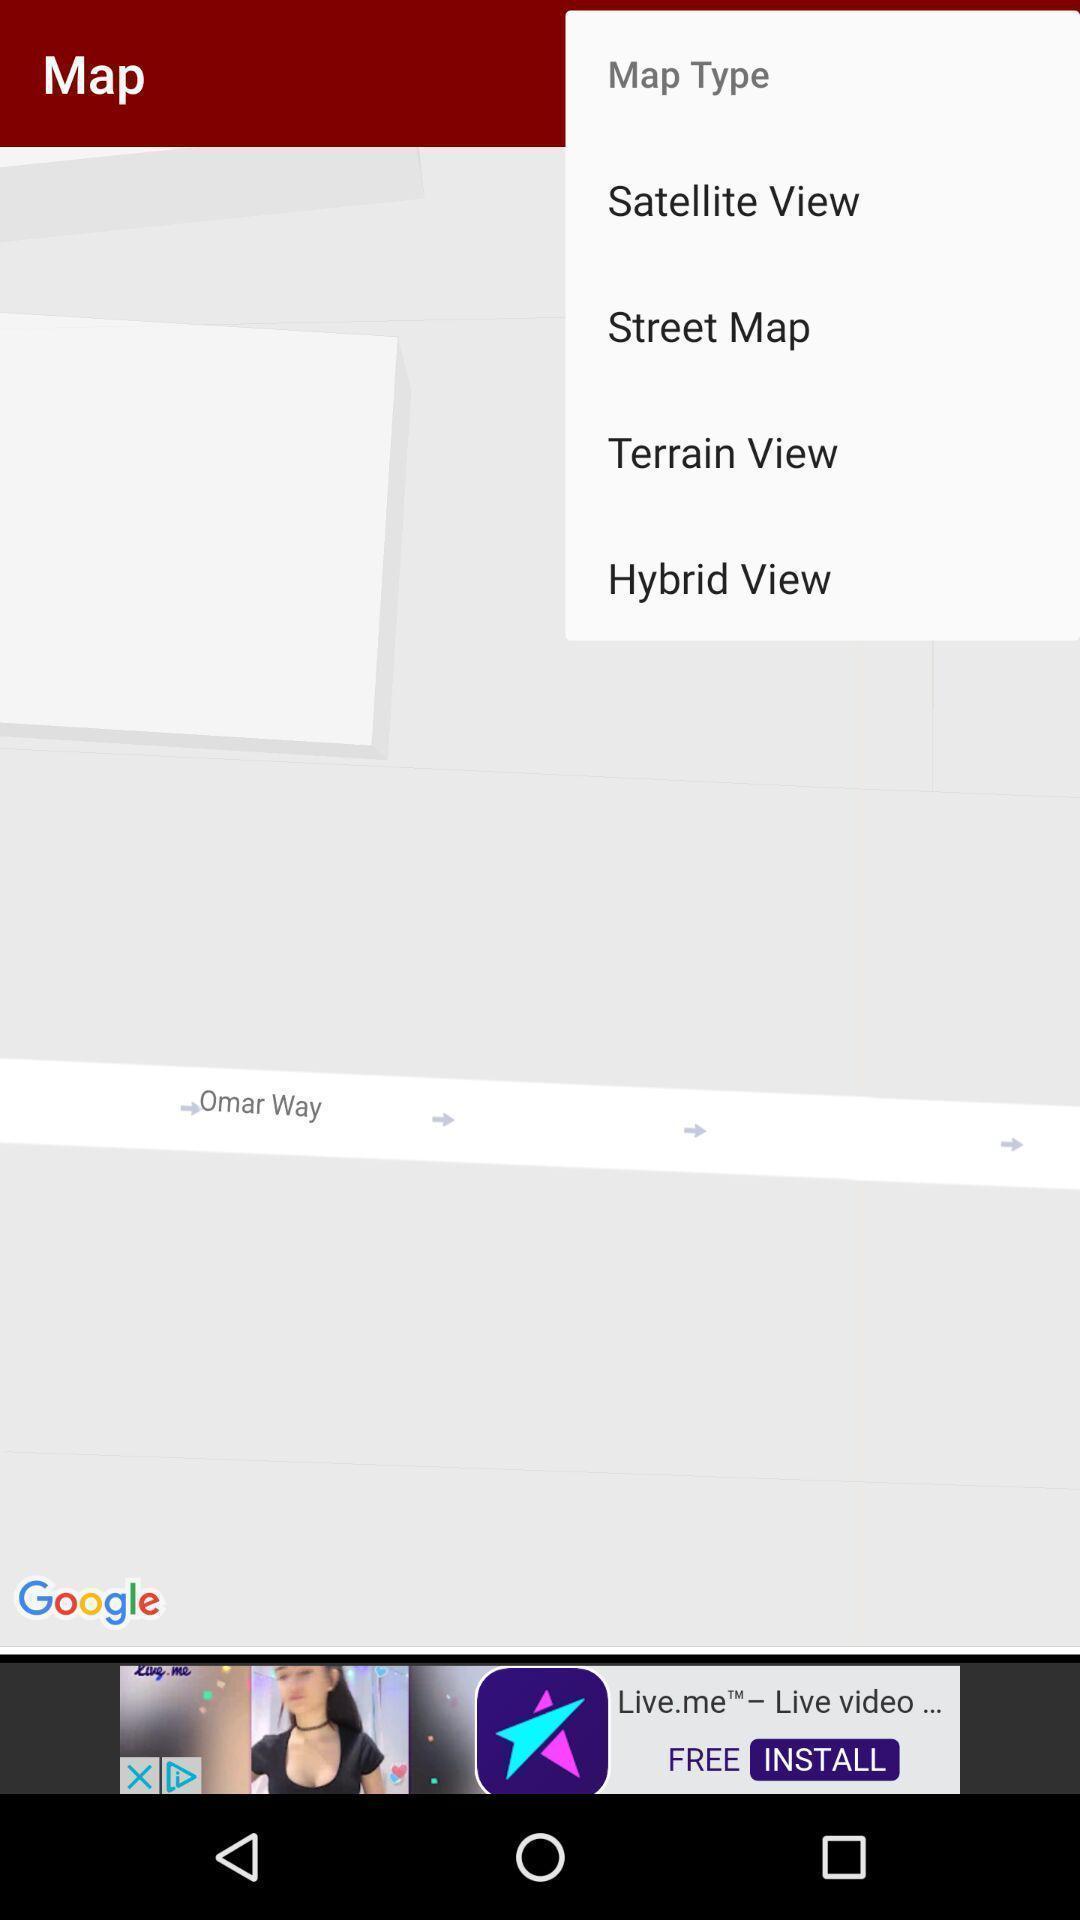Tell me about the visual elements in this screen capture. Screen displaying types of map. 